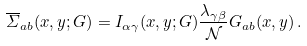Convert formula to latex. <formula><loc_0><loc_0><loc_500><loc_500>\overline { \varSigma } _ { a b } ( x , y ; G ) = I _ { \alpha \gamma } ( x , y ; G ) \frac { \lambda _ { \gamma \beta } } { \mathcal { N } } G _ { a b } ( x , y ) \, .</formula> 